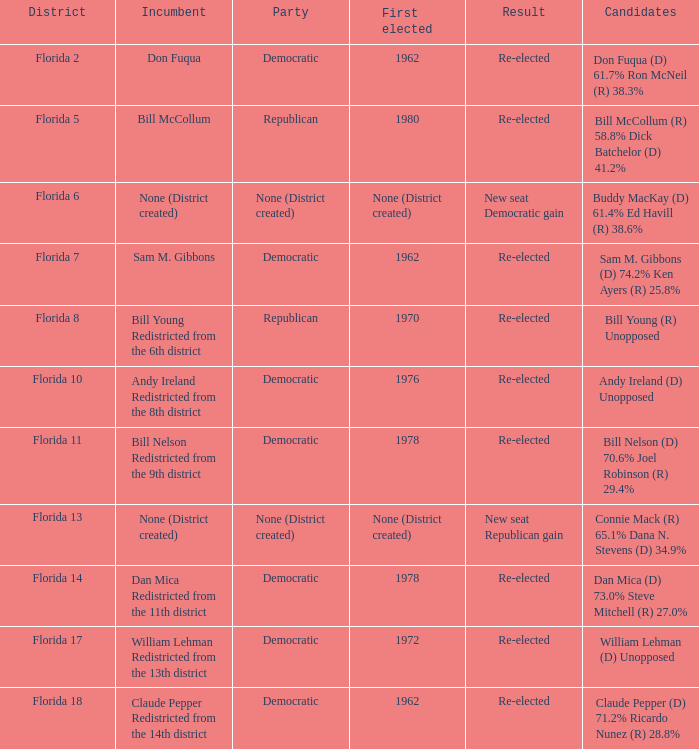How many nominees with outcome being new seat democratic gain? 1.0. 